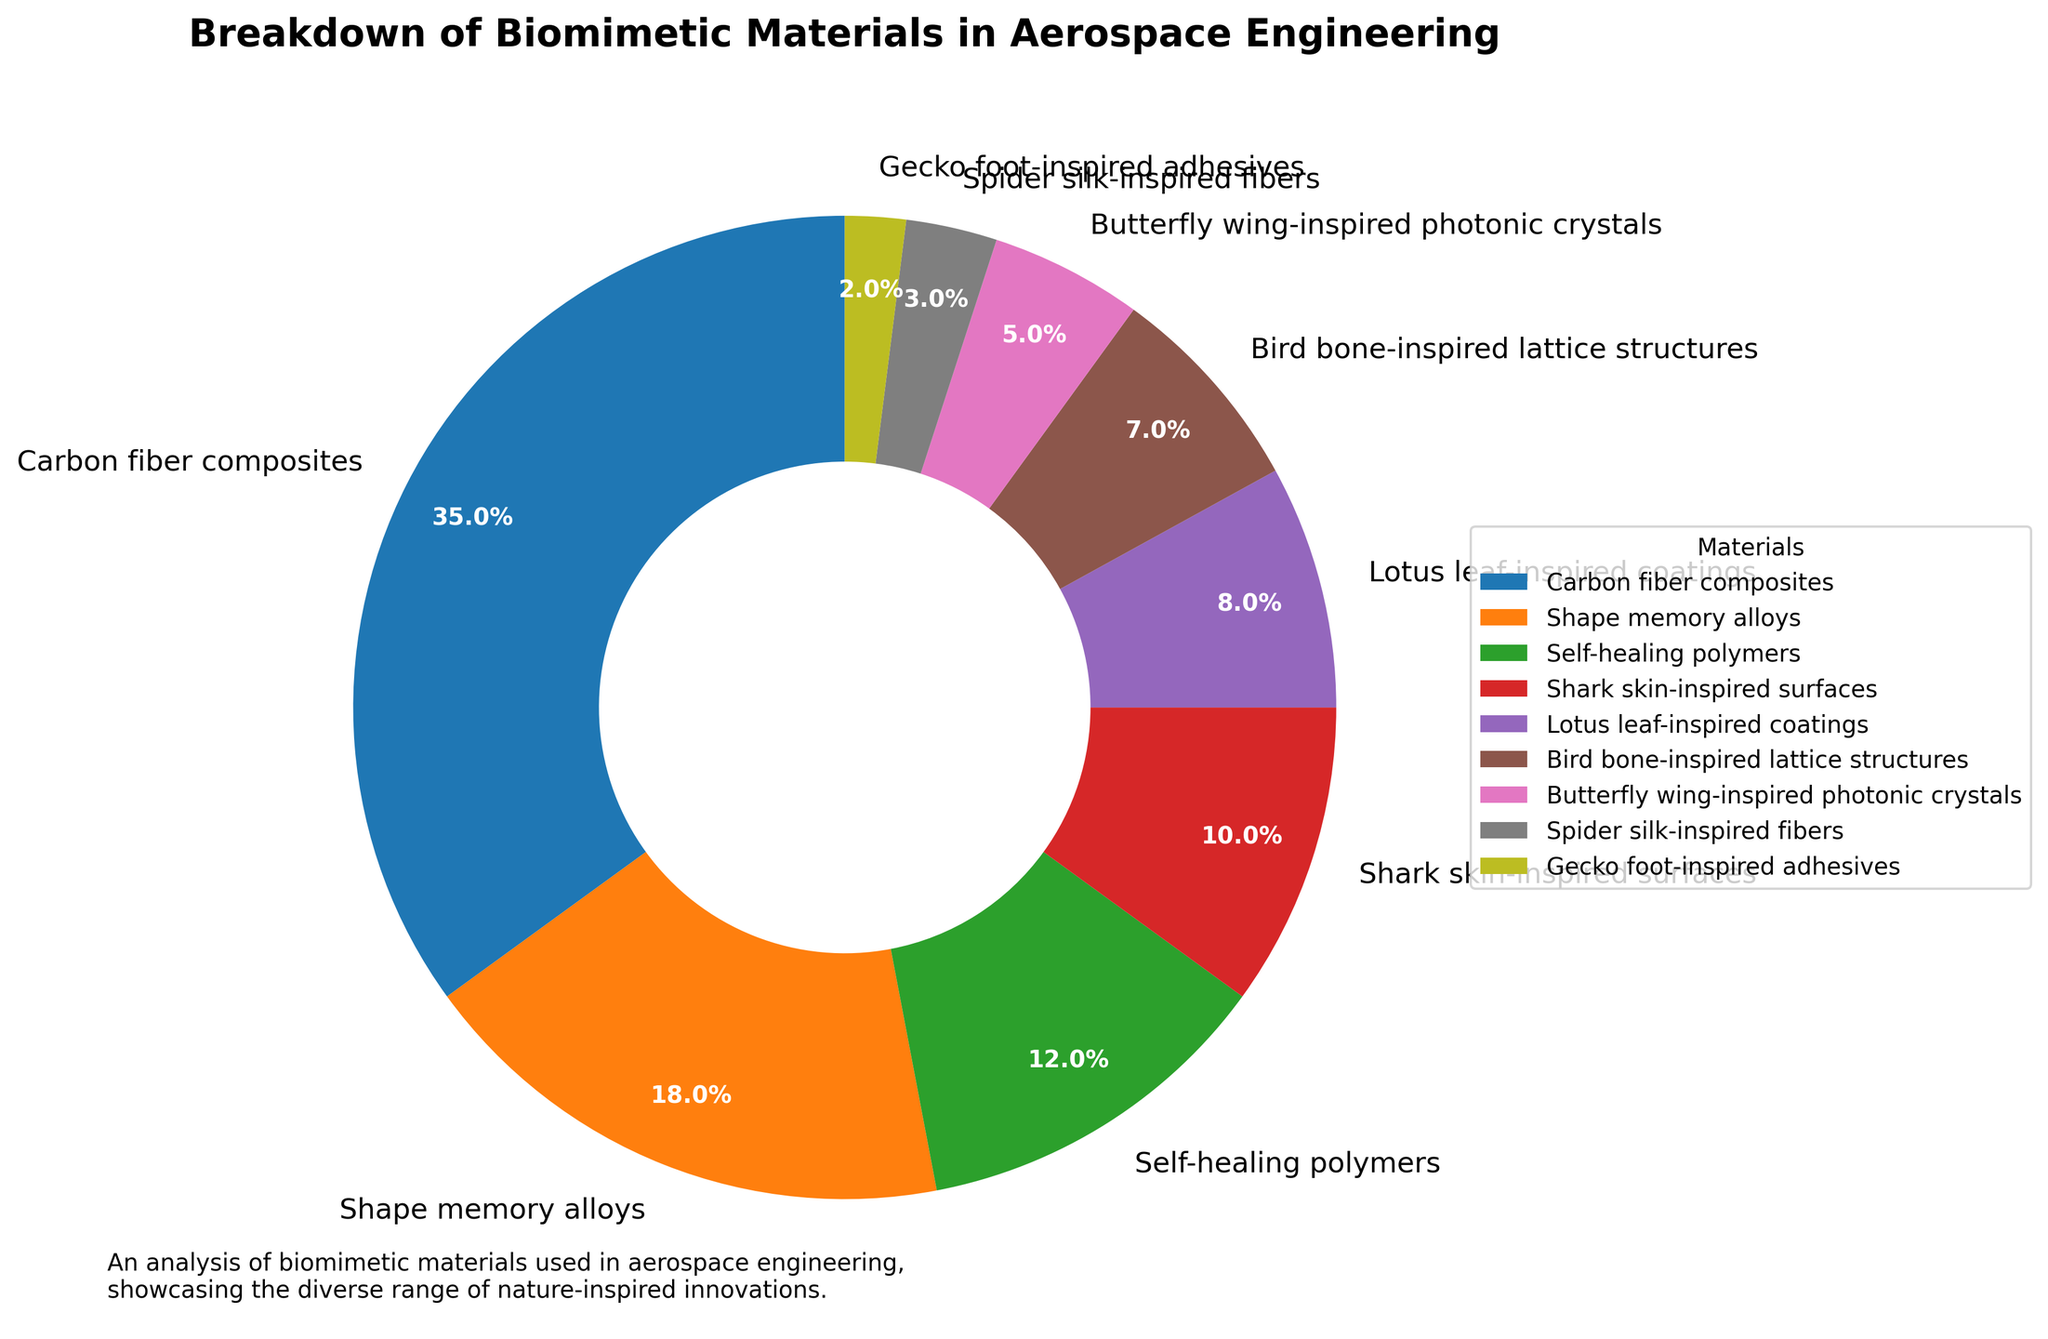Which material has the highest percentage? The largest section in the pie chart corresponds to carbon fiber composites, indicated by both its size and label.
Answer: Carbon fiber composites Which two materials collectively make up 20% of the breakdown? Shark skin-inspired surfaces contribute 10%, and lotus leaf-inspired coatings contribute 8%; together, these sum to 18%. Another way to reach closer to 20% is by considering bird bone-inspired lattice structures (7%) and butterfly wing-inspired photonic crystals (5%), which sum up to 12%. But the closest to exactly 20% is combining shark skin-inspired surfaces (10%) and gecko foot-inspired adhesives (2%), summing up to 12%.
Answer: None exactly Which material contributes the least to the breakdown? The smallest section in the pie chart belongs to gecko foot-inspired adhesives at 2%. This is indicated by both its size and label.
Answer: Gecko foot-inspired adhesives How much more significant is the contribution of shape memory alloys compared to butterfly wing-inspired photonic crystals? Shape memory alloys contribute 18%, while butterfly wing-inspired photonic crystals contribute 5%; the difference is 18% - 5% = 13%.
Answer: 13% List the materials that collectively make up less than 10% of the breakdown. Looking at the pie chart, butterfly wing-inspired photonic crystals (5%), spider silk-inspired fibers (3%), and gecko foot-inspired adhesives (2%) collectively sum up to 5% + 3% + 2% = 10%.
Answer: Gecko foot-inspired adhesives, spider silk-inspired fibers, butterfly wing-inspired photonic crystals Which materials have a percentage contribution that is less than or equal to that of self-healing polymers? Materials with percentages less than 12% (self-healing polymers) include shark skin-inspired surfaces (10%), lotus leaf-inspired coatings (8%), bird bone-inspired lattice structures (7%), butterfly wing-inspired photonic crystals (5%), spider silk-inspired fibers (3%), and gecko foot-inspired adhesives (2%).
Answer: Gecko foot-inspired adhesives, spider silk-inspired fibers, butterfly wing-inspired photonic crystals, bird bone-inspired lattice structures, lotus leaf-inspired coatings, shark skin-inspired surfaces Is the contribution of carbon fiber composites more than double that of shape memory alloys? Carbon fiber composites contribute 35%, and shape memory alloys contribute 18%. Double of 18% is 36%, which is slightly more than 35%.
Answer: No 